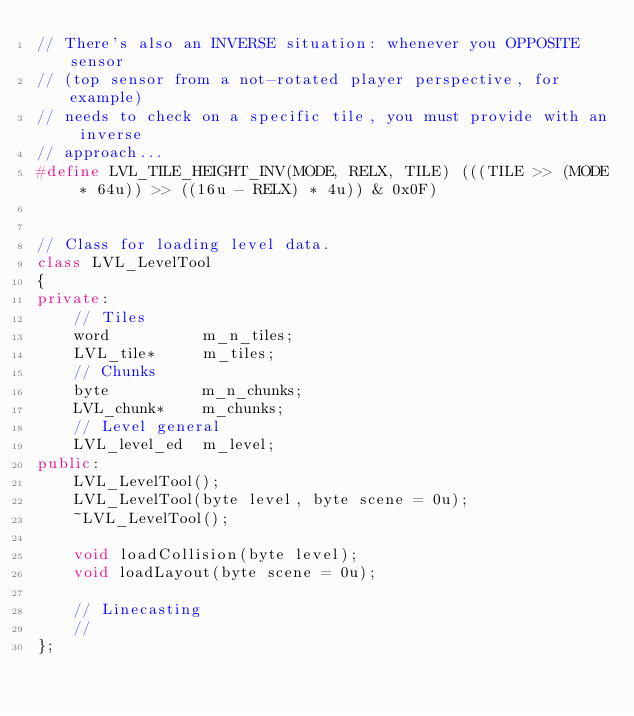Convert code to text. <code><loc_0><loc_0><loc_500><loc_500><_C++_>// There's also an INVERSE situation: whenever you OPPOSITE sensor
// (top sensor from a not-rotated player perspective, for example)
// needs to check on a specific tile, you must provide with an inverse
// approach...
#define LVL_TILE_HEIGHT_INV(MODE, RELX, TILE) (((TILE >> (MODE * 64u)) >> ((16u - RELX) * 4u)) & 0x0F)


// Class for loading level data.
class LVL_LevelTool
{
private:
    // Tiles
    word          m_n_tiles;
    LVL_tile*     m_tiles;
    // Chunks
    byte          m_n_chunks;
    LVL_chunk*    m_chunks;
    // Level general
    LVL_level_ed  m_level;
public:
    LVL_LevelTool();
    LVL_LevelTool(byte level, byte scene = 0u);
    ~LVL_LevelTool();

    void loadCollision(byte level);
    void loadLayout(byte scene = 0u);

    // Linecasting
    // 
};</code> 